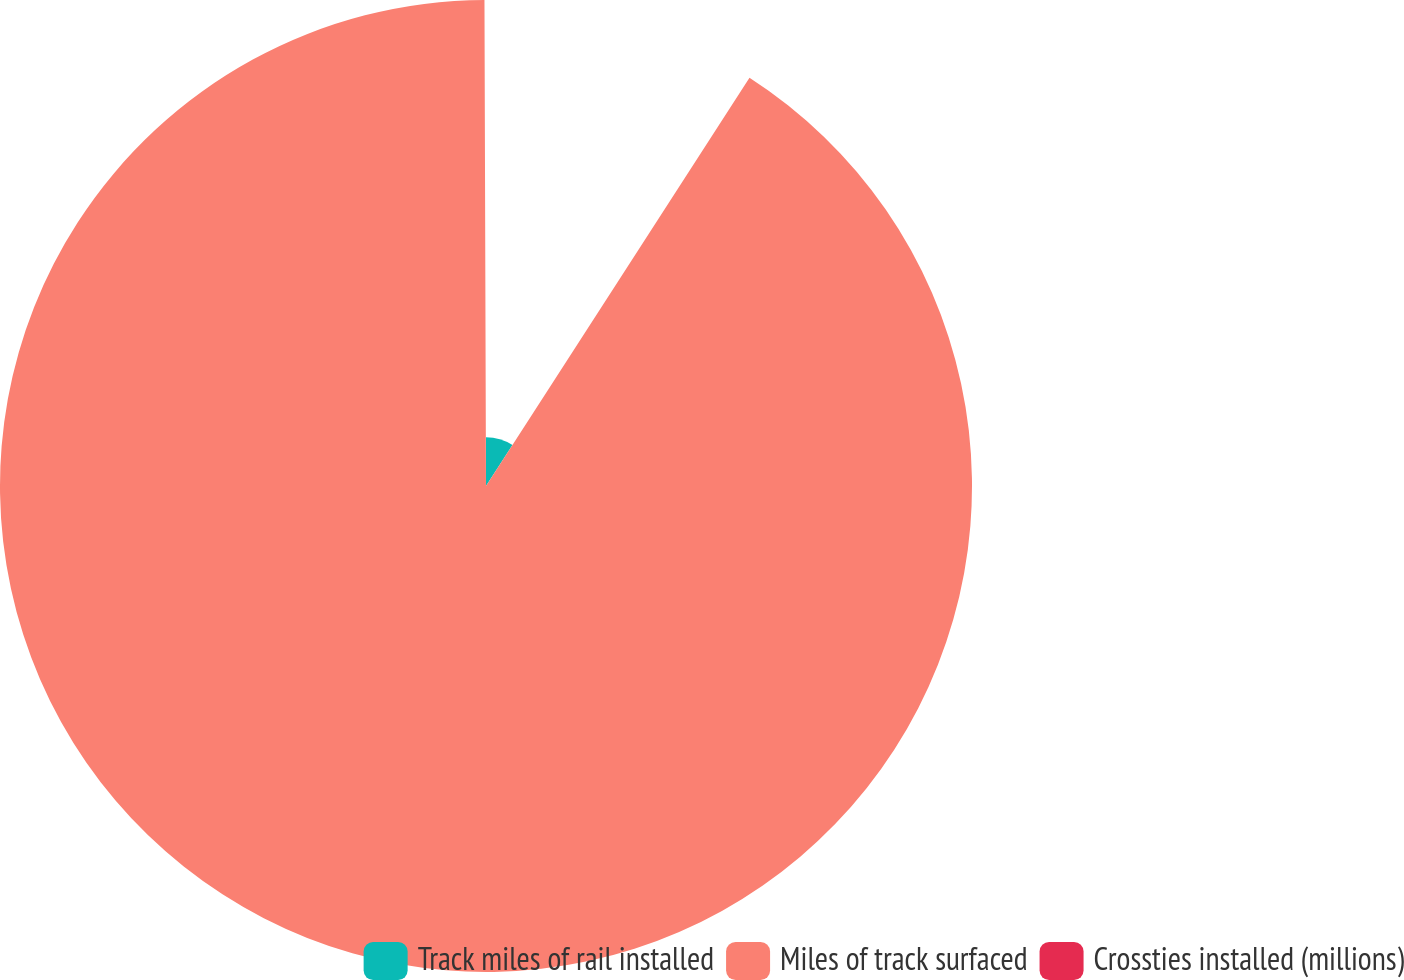<chart> <loc_0><loc_0><loc_500><loc_500><pie_chart><fcel>Track miles of rail installed<fcel>Miles of track surfaced<fcel>Crossties installed (millions)<nl><fcel>9.12%<fcel>90.83%<fcel>0.05%<nl></chart> 